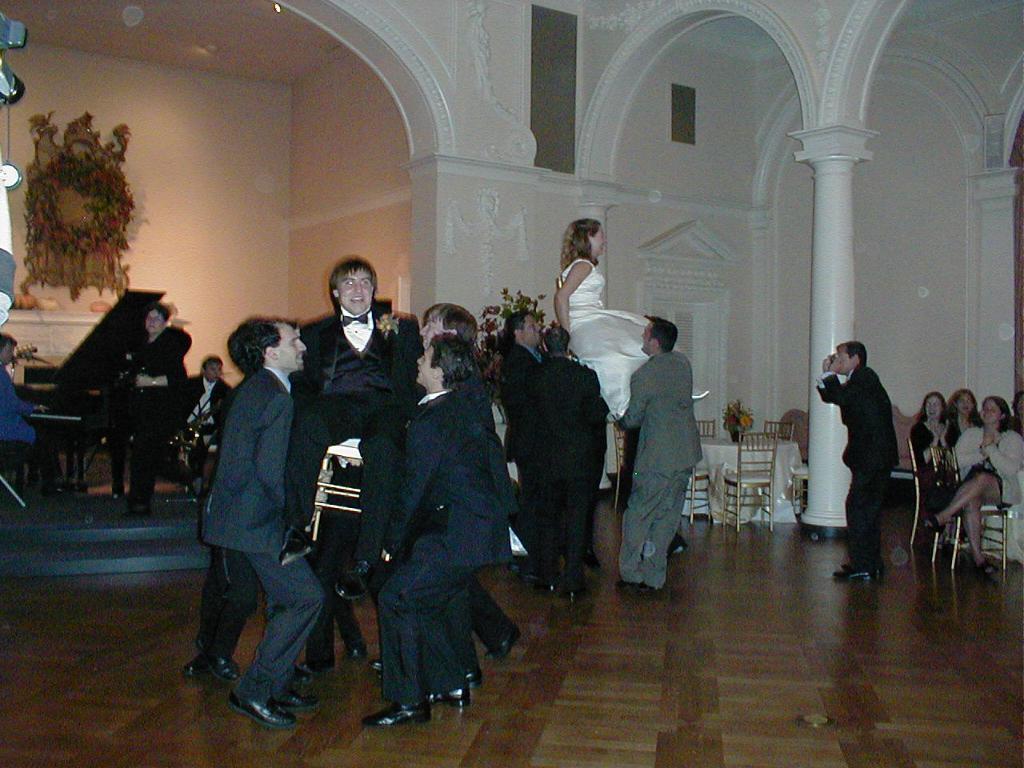Can you describe this image briefly? This image is taken indoors. At the bottom of the image there is a floor. In the background there are a few walls with carvings and there is a pillar. There are a few musical instruments. There is an architecture and there is a table with a few things on it. On the right side of the image a few women are sitting on the chairs. A man is standing on the floor. There are a few empty chairs and a table with a flower vase and a table cloth on it. In the middle of the image there are a few people standing and lifting a man and a woman. 